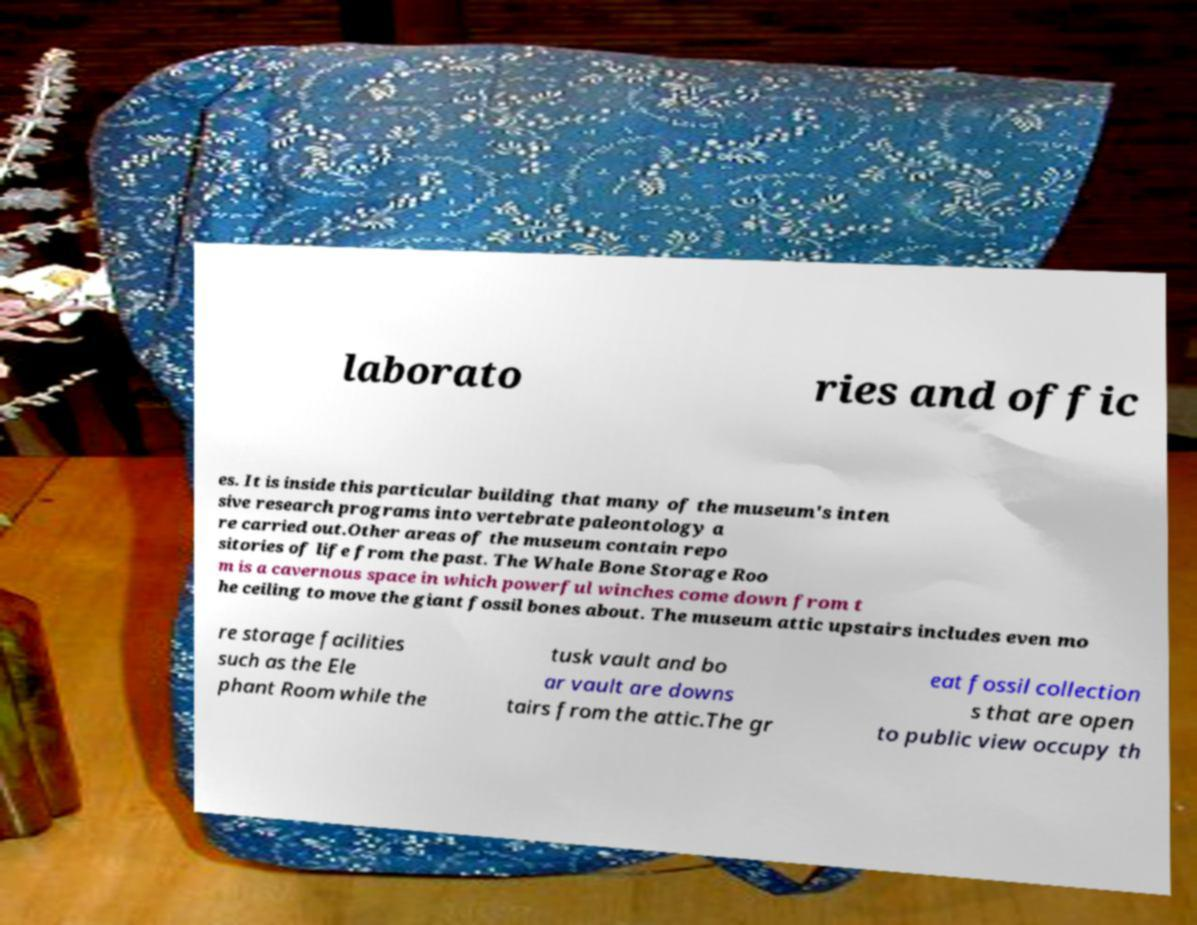There's text embedded in this image that I need extracted. Can you transcribe it verbatim? laborato ries and offic es. It is inside this particular building that many of the museum's inten sive research programs into vertebrate paleontology a re carried out.Other areas of the museum contain repo sitories of life from the past. The Whale Bone Storage Roo m is a cavernous space in which powerful winches come down from t he ceiling to move the giant fossil bones about. The museum attic upstairs includes even mo re storage facilities such as the Ele phant Room while the tusk vault and bo ar vault are downs tairs from the attic.The gr eat fossil collection s that are open to public view occupy th 